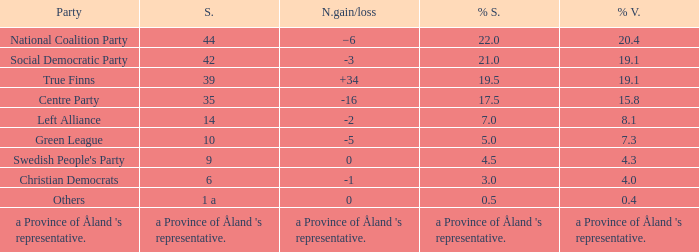Regarding the seats that casted 8.1% of the vote how many seats were held? 14.0. 